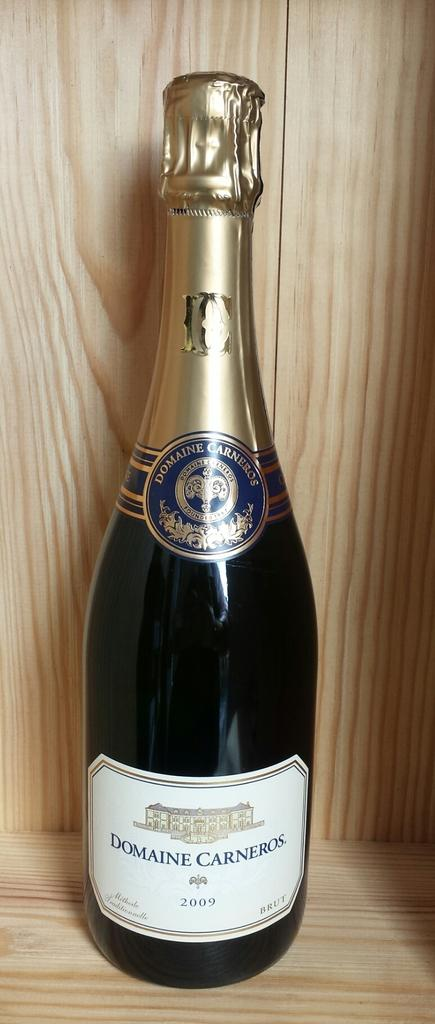<image>
Give a short and clear explanation of the subsequent image. A bottle of 2009 Domaine Carneros rests inside a wooden container. 